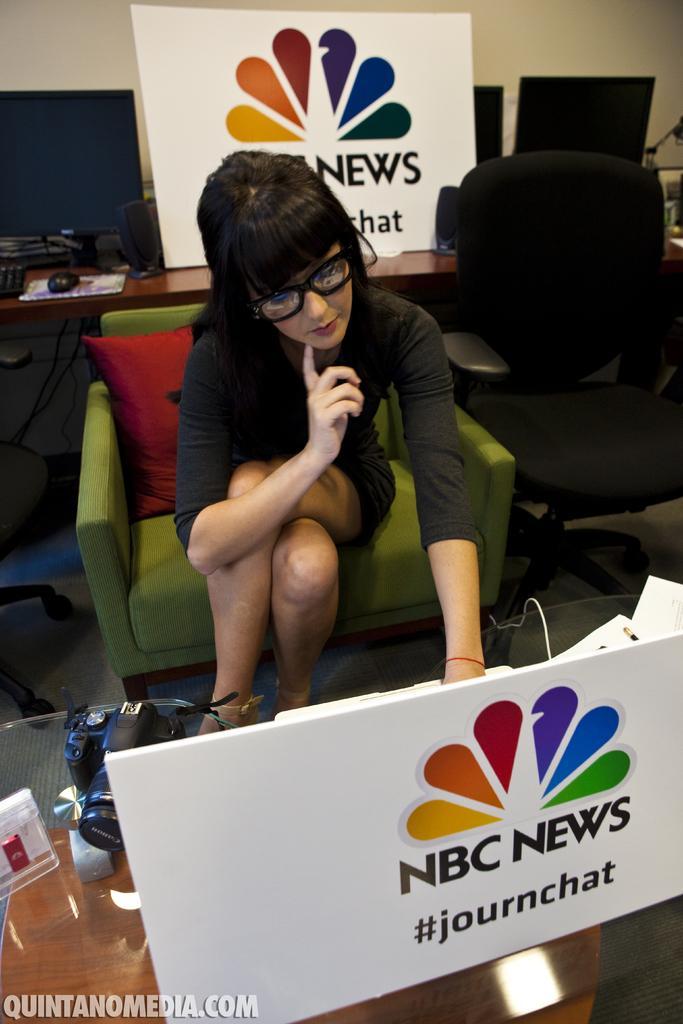How would you summarize this image in a sentence or two? In this picture we can see a woman who is sitting on the sofa. This is board. Here we can see a table and there is a camera. On the background we can see some monitors. And this is wall. 